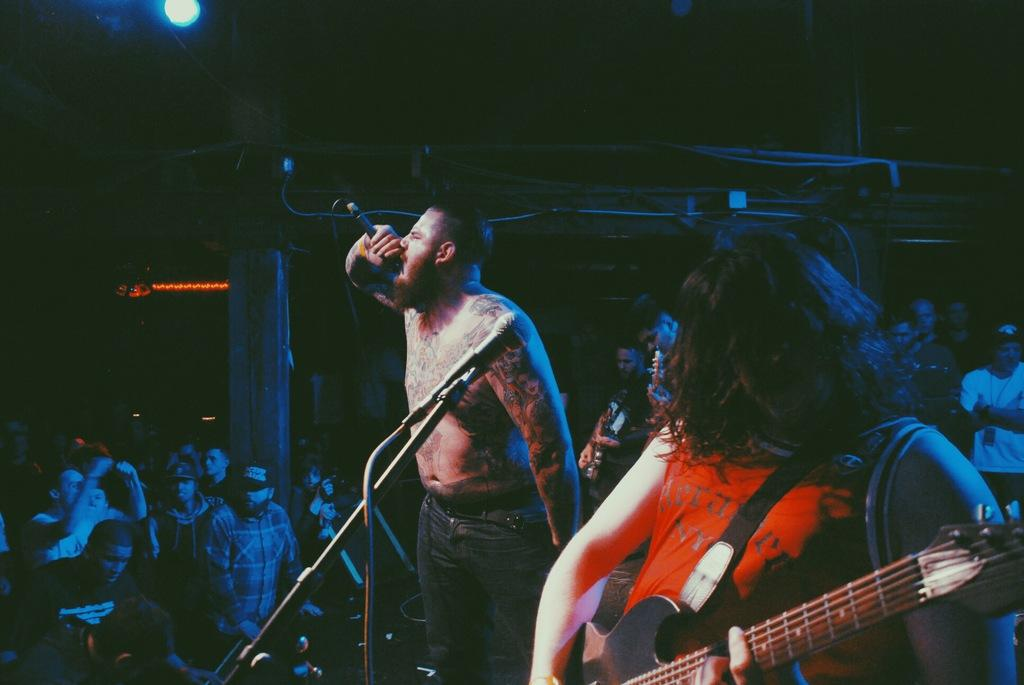What is the man in the image wearing? The man is wearing jeans in the image. What is the man holding in the image? The man is holding a mic in the image. What is the man doing in the image? The man is singing in the image. Can you describe the other man in the image? The other man is wearing a red t-shirt in the image. What is the other man holding in the image? The other man is holding a guitar in the image. How many people are visible in the image? There are many people standing in the image. What type of knowledge can be seen in the image? There is no knowledge visible in the image; it features people and musical instruments. What type of nut is being cracked by the man in the image? There is no nut present in the image, and the man is not performing any action related to cracking nuts. 